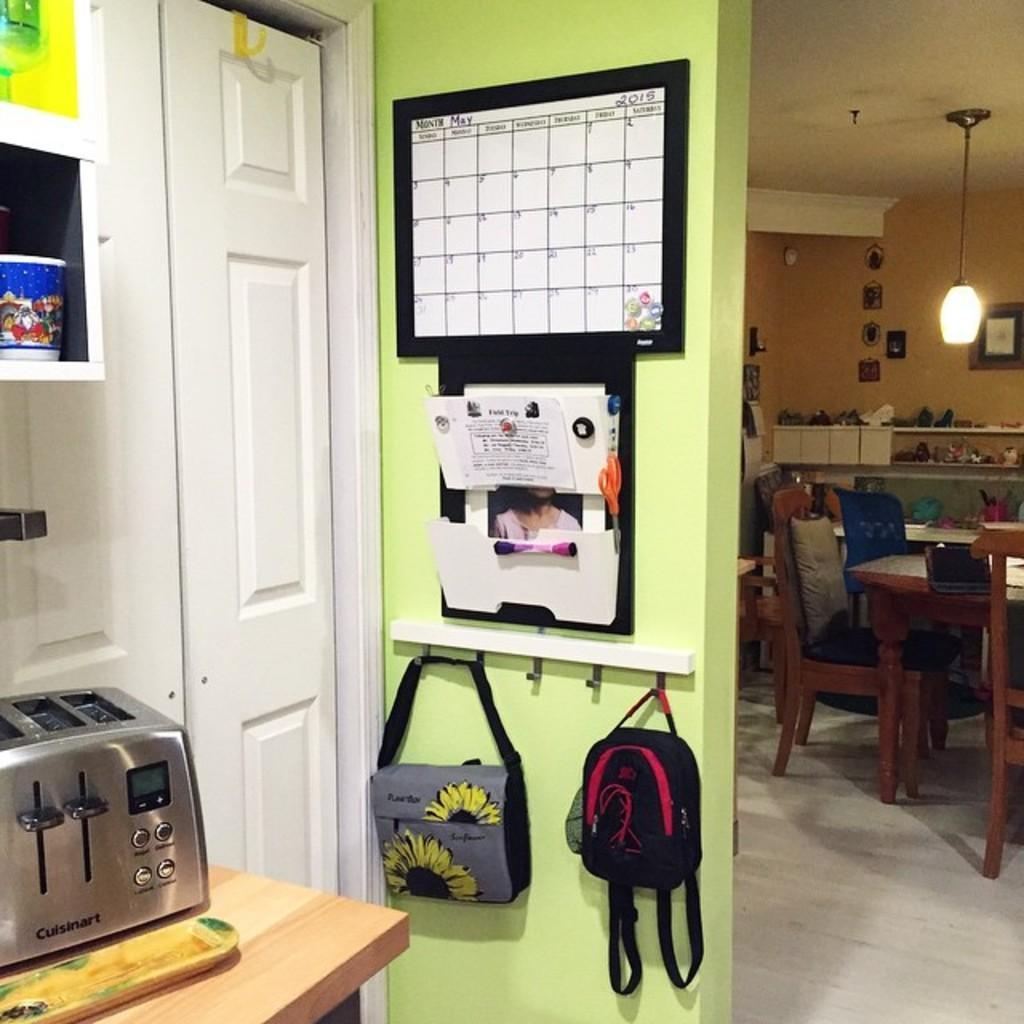What color is the wall in the image? The wall in the image is green. What feature is present on the wall? The wall has a door. What items are hanging on the wall? There are two bags hanging on the wall. What furniture can be seen on the right side of the image? There is a table on the right side of the image. What objects are on the floor in the image? There are chairs on the floor in the image. Where is the baby playing in the image? There is no baby present in the image. How many eggs are visible on the table in the image? There are no eggs visible on the table in the image. 